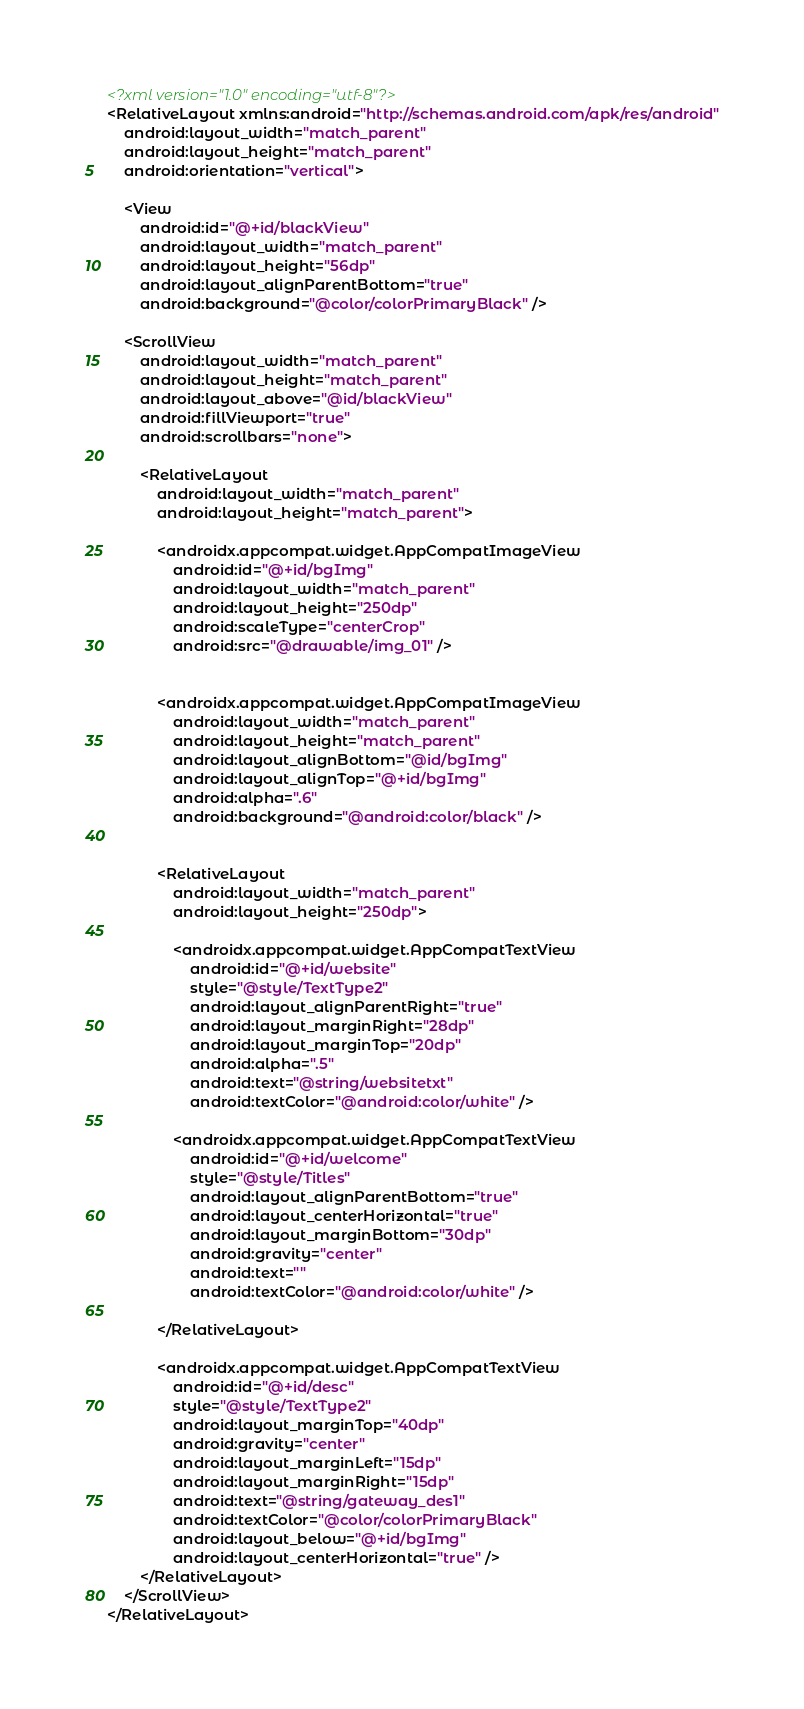Convert code to text. <code><loc_0><loc_0><loc_500><loc_500><_XML_><?xml version="1.0" encoding="utf-8"?>
<RelativeLayout xmlns:android="http://schemas.android.com/apk/res/android"
    android:layout_width="match_parent"
    android:layout_height="match_parent"
    android:orientation="vertical">

    <View
        android:id="@+id/blackView"
        android:layout_width="match_parent"
        android:layout_height="56dp"
        android:layout_alignParentBottom="true"
        android:background="@color/colorPrimaryBlack" />

    <ScrollView
        android:layout_width="match_parent"
        android:layout_height="match_parent"
        android:layout_above="@id/blackView"
        android:fillViewport="true"
        android:scrollbars="none">

        <RelativeLayout
            android:layout_width="match_parent"
            android:layout_height="match_parent">

            <androidx.appcompat.widget.AppCompatImageView
                android:id="@+id/bgImg"
                android:layout_width="match_parent"
                android:layout_height="250dp"
                android:scaleType="centerCrop"
                android:src="@drawable/img_01" />


            <androidx.appcompat.widget.AppCompatImageView
                android:layout_width="match_parent"
                android:layout_height="match_parent"
                android:layout_alignBottom="@id/bgImg"
                android:layout_alignTop="@+id/bgImg"
                android:alpha=".6"
                android:background="@android:color/black" />


            <RelativeLayout
                android:layout_width="match_parent"
                android:layout_height="250dp">

                <androidx.appcompat.widget.AppCompatTextView
                    android:id="@+id/website"
                    style="@style/TextType2"
                    android:layout_alignParentRight="true"
                    android:layout_marginRight="28dp"
                    android:layout_marginTop="20dp"
                    android:alpha=".5"
                    android:text="@string/websitetxt"
                    android:textColor="@android:color/white" />

                <androidx.appcompat.widget.AppCompatTextView
                    android:id="@+id/welcome"
                    style="@style/Titles"
                    android:layout_alignParentBottom="true"
                    android:layout_centerHorizontal="true"
                    android:layout_marginBottom="30dp"
                    android:gravity="center"
                    android:text=""
                    android:textColor="@android:color/white" />

            </RelativeLayout>

            <androidx.appcompat.widget.AppCompatTextView
                android:id="@+id/desc"
                style="@style/TextType2"
                android:layout_marginTop="40dp"
                android:gravity="center"
                android:layout_marginLeft="15dp"
                android:layout_marginRight="15dp"
                android:text="@string/gateway_des1"
                android:textColor="@color/colorPrimaryBlack"
                android:layout_below="@+id/bgImg"
                android:layout_centerHorizontal="true" />
        </RelativeLayout>
    </ScrollView>
</RelativeLayout>
</code> 